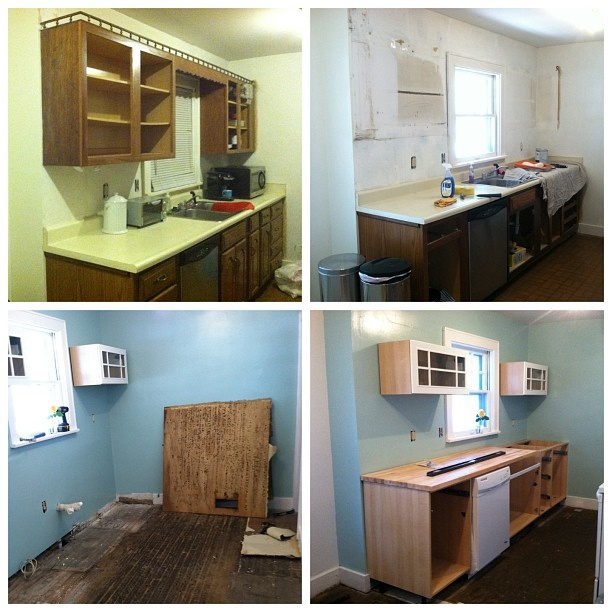Describe the objects in this image and their specific colors. I can see microwave in ivory, black, gray, olive, and darkgreen tones, sink in ivory, darkgreen, gray, olive, and black tones, sink in ivory, gray, darkblue, and darkgray tones, and bottle in ivory, lightgray, darkgray, and gray tones in this image. 